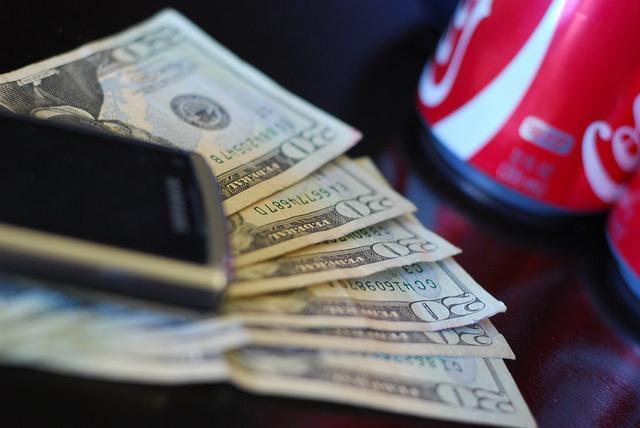How many chairs don't have a dog on them?
Give a very brief answer. 0. 